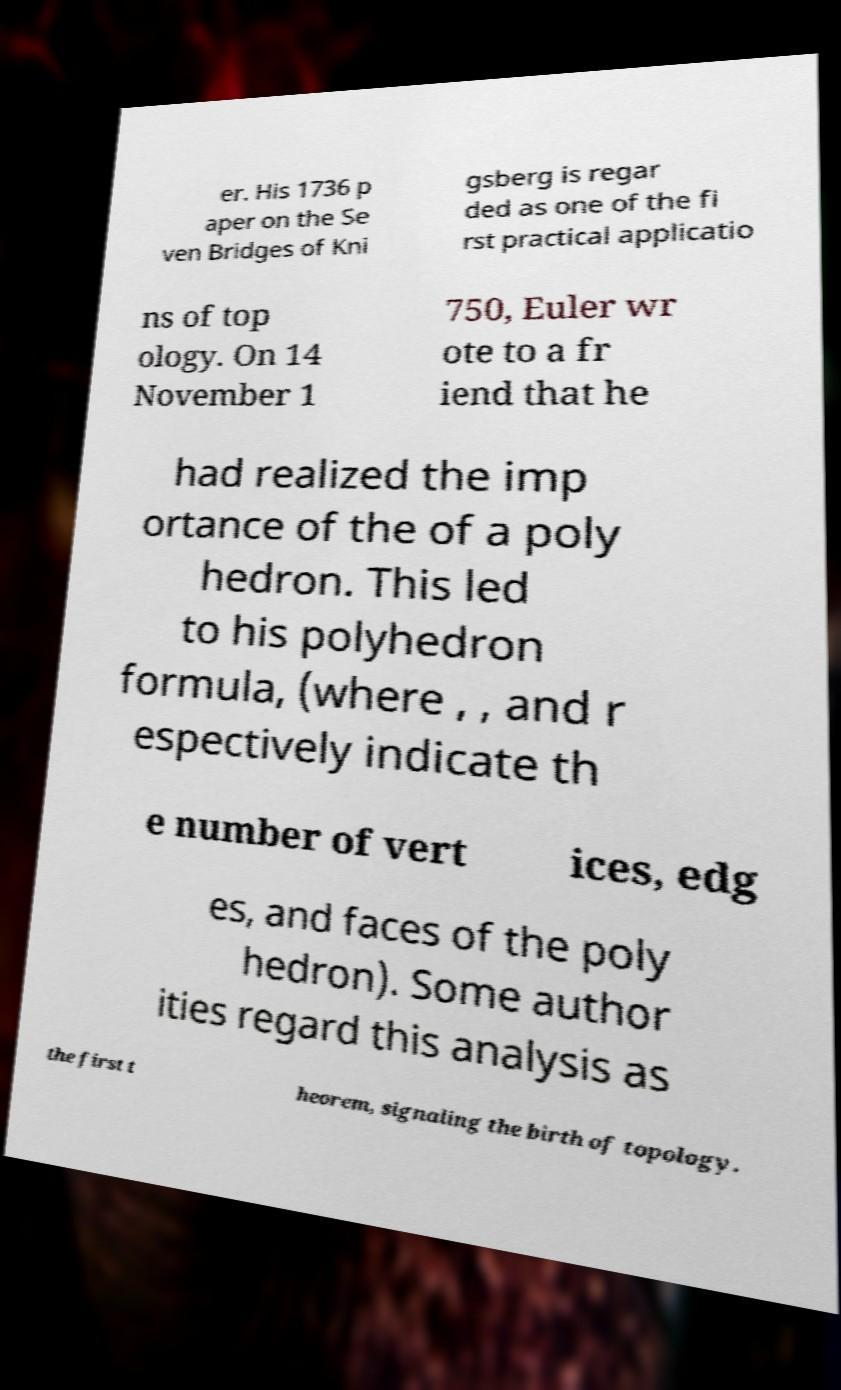Could you extract and type out the text from this image? er. His 1736 p aper on the Se ven Bridges of Kni gsberg is regar ded as one of the fi rst practical applicatio ns of top ology. On 14 November 1 750, Euler wr ote to a fr iend that he had realized the imp ortance of the of a poly hedron. This led to his polyhedron formula, (where , , and r espectively indicate th e number of vert ices, edg es, and faces of the poly hedron). Some author ities regard this analysis as the first t heorem, signaling the birth of topology. 